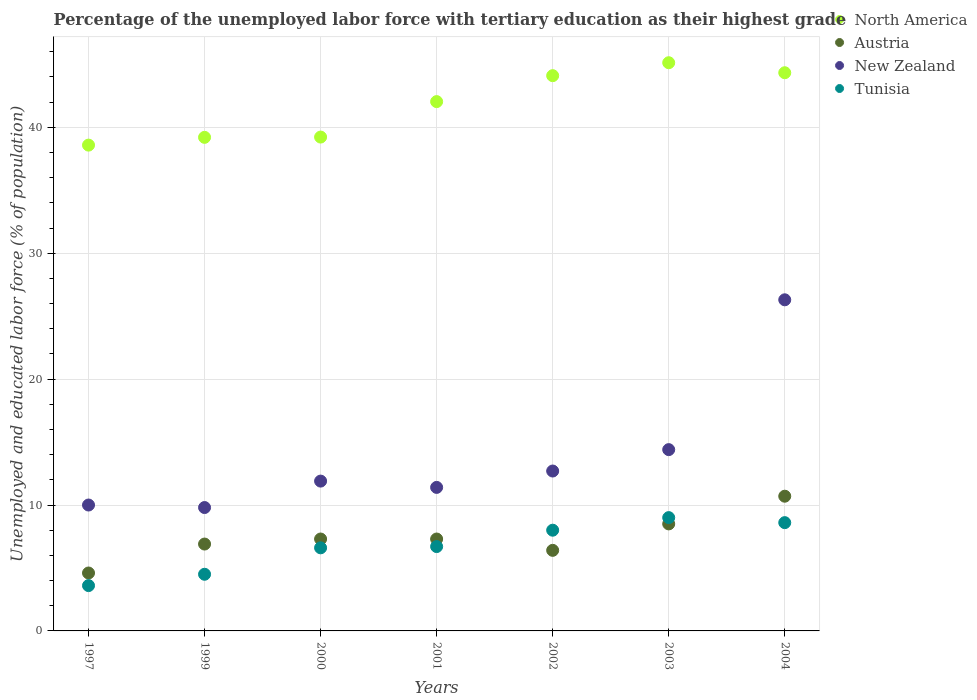How many different coloured dotlines are there?
Your answer should be very brief. 4. What is the percentage of the unemployed labor force with tertiary education in North America in 1997?
Ensure brevity in your answer.  38.59. Across all years, what is the maximum percentage of the unemployed labor force with tertiary education in Tunisia?
Give a very brief answer. 9. Across all years, what is the minimum percentage of the unemployed labor force with tertiary education in North America?
Your response must be concise. 38.59. What is the total percentage of the unemployed labor force with tertiary education in North America in the graph?
Provide a succinct answer. 292.63. What is the difference between the percentage of the unemployed labor force with tertiary education in Tunisia in 1999 and that in 2004?
Your response must be concise. -4.1. What is the difference between the percentage of the unemployed labor force with tertiary education in New Zealand in 1997 and the percentage of the unemployed labor force with tertiary education in Tunisia in 1999?
Make the answer very short. 5.5. What is the average percentage of the unemployed labor force with tertiary education in Tunisia per year?
Your answer should be compact. 6.71. In the year 2003, what is the difference between the percentage of the unemployed labor force with tertiary education in Austria and percentage of the unemployed labor force with tertiary education in New Zealand?
Your response must be concise. -5.9. What is the ratio of the percentage of the unemployed labor force with tertiary education in Austria in 2000 to that in 2004?
Keep it short and to the point. 0.68. Is the percentage of the unemployed labor force with tertiary education in North America in 2000 less than that in 2002?
Your response must be concise. Yes. Is the difference between the percentage of the unemployed labor force with tertiary education in Austria in 2001 and 2004 greater than the difference between the percentage of the unemployed labor force with tertiary education in New Zealand in 2001 and 2004?
Provide a succinct answer. Yes. What is the difference between the highest and the second highest percentage of the unemployed labor force with tertiary education in North America?
Offer a terse response. 0.8. What is the difference between the highest and the lowest percentage of the unemployed labor force with tertiary education in Austria?
Your response must be concise. 6.1. Is the sum of the percentage of the unemployed labor force with tertiary education in North America in 1999 and 2003 greater than the maximum percentage of the unemployed labor force with tertiary education in Tunisia across all years?
Offer a very short reply. Yes. Is it the case that in every year, the sum of the percentage of the unemployed labor force with tertiary education in New Zealand and percentage of the unemployed labor force with tertiary education in North America  is greater than the sum of percentage of the unemployed labor force with tertiary education in Austria and percentage of the unemployed labor force with tertiary education in Tunisia?
Offer a very short reply. Yes. Does the percentage of the unemployed labor force with tertiary education in North America monotonically increase over the years?
Your answer should be compact. No. Are the values on the major ticks of Y-axis written in scientific E-notation?
Your answer should be compact. No. Does the graph contain any zero values?
Your response must be concise. No. Where does the legend appear in the graph?
Your answer should be very brief. Top right. How many legend labels are there?
Keep it short and to the point. 4. What is the title of the graph?
Offer a very short reply. Percentage of the unemployed labor force with tertiary education as their highest grade. Does "Haiti" appear as one of the legend labels in the graph?
Make the answer very short. No. What is the label or title of the Y-axis?
Your response must be concise. Unemployed and educated labor force (% of population). What is the Unemployed and educated labor force (% of population) in North America in 1997?
Your answer should be compact. 38.59. What is the Unemployed and educated labor force (% of population) of Austria in 1997?
Offer a terse response. 4.6. What is the Unemployed and educated labor force (% of population) of Tunisia in 1997?
Keep it short and to the point. 3.6. What is the Unemployed and educated labor force (% of population) in North America in 1999?
Ensure brevity in your answer.  39.2. What is the Unemployed and educated labor force (% of population) of Austria in 1999?
Your answer should be compact. 6.9. What is the Unemployed and educated labor force (% of population) in New Zealand in 1999?
Provide a succinct answer. 9.8. What is the Unemployed and educated labor force (% of population) in North America in 2000?
Provide a short and direct response. 39.23. What is the Unemployed and educated labor force (% of population) in Austria in 2000?
Give a very brief answer. 7.3. What is the Unemployed and educated labor force (% of population) of New Zealand in 2000?
Offer a terse response. 11.9. What is the Unemployed and educated labor force (% of population) of Tunisia in 2000?
Your response must be concise. 6.6. What is the Unemployed and educated labor force (% of population) of North America in 2001?
Your answer should be very brief. 42.04. What is the Unemployed and educated labor force (% of population) of Austria in 2001?
Offer a very short reply. 7.3. What is the Unemployed and educated labor force (% of population) in New Zealand in 2001?
Provide a short and direct response. 11.4. What is the Unemployed and educated labor force (% of population) of Tunisia in 2001?
Provide a succinct answer. 6.7. What is the Unemployed and educated labor force (% of population) in North America in 2002?
Offer a very short reply. 44.1. What is the Unemployed and educated labor force (% of population) of Austria in 2002?
Keep it short and to the point. 6.4. What is the Unemployed and educated labor force (% of population) in New Zealand in 2002?
Make the answer very short. 12.7. What is the Unemployed and educated labor force (% of population) in North America in 2003?
Your answer should be very brief. 45.13. What is the Unemployed and educated labor force (% of population) of New Zealand in 2003?
Offer a terse response. 14.4. What is the Unemployed and educated labor force (% of population) in Tunisia in 2003?
Provide a succinct answer. 9. What is the Unemployed and educated labor force (% of population) in North America in 2004?
Give a very brief answer. 44.34. What is the Unemployed and educated labor force (% of population) of Austria in 2004?
Provide a short and direct response. 10.7. What is the Unemployed and educated labor force (% of population) of New Zealand in 2004?
Give a very brief answer. 26.3. What is the Unemployed and educated labor force (% of population) in Tunisia in 2004?
Ensure brevity in your answer.  8.6. Across all years, what is the maximum Unemployed and educated labor force (% of population) of North America?
Keep it short and to the point. 45.13. Across all years, what is the maximum Unemployed and educated labor force (% of population) of Austria?
Your response must be concise. 10.7. Across all years, what is the maximum Unemployed and educated labor force (% of population) in New Zealand?
Offer a very short reply. 26.3. Across all years, what is the maximum Unemployed and educated labor force (% of population) of Tunisia?
Your response must be concise. 9. Across all years, what is the minimum Unemployed and educated labor force (% of population) in North America?
Your answer should be very brief. 38.59. Across all years, what is the minimum Unemployed and educated labor force (% of population) of Austria?
Provide a short and direct response. 4.6. Across all years, what is the minimum Unemployed and educated labor force (% of population) in New Zealand?
Offer a terse response. 9.8. Across all years, what is the minimum Unemployed and educated labor force (% of population) in Tunisia?
Make the answer very short. 3.6. What is the total Unemployed and educated labor force (% of population) in North America in the graph?
Make the answer very short. 292.63. What is the total Unemployed and educated labor force (% of population) of Austria in the graph?
Ensure brevity in your answer.  51.7. What is the total Unemployed and educated labor force (% of population) in New Zealand in the graph?
Make the answer very short. 96.5. What is the total Unemployed and educated labor force (% of population) in Tunisia in the graph?
Keep it short and to the point. 47. What is the difference between the Unemployed and educated labor force (% of population) in North America in 1997 and that in 1999?
Offer a very short reply. -0.62. What is the difference between the Unemployed and educated labor force (% of population) in New Zealand in 1997 and that in 1999?
Your answer should be compact. 0.2. What is the difference between the Unemployed and educated labor force (% of population) of Tunisia in 1997 and that in 1999?
Your answer should be very brief. -0.9. What is the difference between the Unemployed and educated labor force (% of population) in North America in 1997 and that in 2000?
Give a very brief answer. -0.64. What is the difference between the Unemployed and educated labor force (% of population) of Austria in 1997 and that in 2000?
Make the answer very short. -2.7. What is the difference between the Unemployed and educated labor force (% of population) of New Zealand in 1997 and that in 2000?
Offer a very short reply. -1.9. What is the difference between the Unemployed and educated labor force (% of population) in Tunisia in 1997 and that in 2000?
Give a very brief answer. -3. What is the difference between the Unemployed and educated labor force (% of population) of North America in 1997 and that in 2001?
Give a very brief answer. -3.46. What is the difference between the Unemployed and educated labor force (% of population) in North America in 1997 and that in 2002?
Give a very brief answer. -5.52. What is the difference between the Unemployed and educated labor force (% of population) in Austria in 1997 and that in 2002?
Your response must be concise. -1.8. What is the difference between the Unemployed and educated labor force (% of population) in New Zealand in 1997 and that in 2002?
Your answer should be compact. -2.7. What is the difference between the Unemployed and educated labor force (% of population) in North America in 1997 and that in 2003?
Make the answer very short. -6.54. What is the difference between the Unemployed and educated labor force (% of population) of New Zealand in 1997 and that in 2003?
Keep it short and to the point. -4.4. What is the difference between the Unemployed and educated labor force (% of population) in North America in 1997 and that in 2004?
Your answer should be very brief. -5.75. What is the difference between the Unemployed and educated labor force (% of population) of Austria in 1997 and that in 2004?
Provide a succinct answer. -6.1. What is the difference between the Unemployed and educated labor force (% of population) of New Zealand in 1997 and that in 2004?
Keep it short and to the point. -16.3. What is the difference between the Unemployed and educated labor force (% of population) of Tunisia in 1997 and that in 2004?
Keep it short and to the point. -5. What is the difference between the Unemployed and educated labor force (% of population) in North America in 1999 and that in 2000?
Provide a succinct answer. -0.02. What is the difference between the Unemployed and educated labor force (% of population) in North America in 1999 and that in 2001?
Provide a short and direct response. -2.84. What is the difference between the Unemployed and educated labor force (% of population) in Austria in 1999 and that in 2001?
Your answer should be compact. -0.4. What is the difference between the Unemployed and educated labor force (% of population) in North America in 1999 and that in 2002?
Provide a short and direct response. -4.9. What is the difference between the Unemployed and educated labor force (% of population) of New Zealand in 1999 and that in 2002?
Provide a short and direct response. -2.9. What is the difference between the Unemployed and educated labor force (% of population) in North America in 1999 and that in 2003?
Your answer should be compact. -5.93. What is the difference between the Unemployed and educated labor force (% of population) of New Zealand in 1999 and that in 2003?
Ensure brevity in your answer.  -4.6. What is the difference between the Unemployed and educated labor force (% of population) of North America in 1999 and that in 2004?
Offer a very short reply. -5.13. What is the difference between the Unemployed and educated labor force (% of population) of Austria in 1999 and that in 2004?
Provide a short and direct response. -3.8. What is the difference between the Unemployed and educated labor force (% of population) in New Zealand in 1999 and that in 2004?
Ensure brevity in your answer.  -16.5. What is the difference between the Unemployed and educated labor force (% of population) in Tunisia in 1999 and that in 2004?
Offer a terse response. -4.1. What is the difference between the Unemployed and educated labor force (% of population) in North America in 2000 and that in 2001?
Offer a terse response. -2.82. What is the difference between the Unemployed and educated labor force (% of population) of Austria in 2000 and that in 2001?
Make the answer very short. 0. What is the difference between the Unemployed and educated labor force (% of population) of New Zealand in 2000 and that in 2001?
Ensure brevity in your answer.  0.5. What is the difference between the Unemployed and educated labor force (% of population) in Tunisia in 2000 and that in 2001?
Provide a succinct answer. -0.1. What is the difference between the Unemployed and educated labor force (% of population) of North America in 2000 and that in 2002?
Offer a very short reply. -4.88. What is the difference between the Unemployed and educated labor force (% of population) in Austria in 2000 and that in 2002?
Your response must be concise. 0.9. What is the difference between the Unemployed and educated labor force (% of population) in New Zealand in 2000 and that in 2002?
Offer a terse response. -0.8. What is the difference between the Unemployed and educated labor force (% of population) of Tunisia in 2000 and that in 2002?
Your answer should be very brief. -1.4. What is the difference between the Unemployed and educated labor force (% of population) of North America in 2000 and that in 2003?
Offer a terse response. -5.91. What is the difference between the Unemployed and educated labor force (% of population) of Austria in 2000 and that in 2003?
Provide a succinct answer. -1.2. What is the difference between the Unemployed and educated labor force (% of population) in New Zealand in 2000 and that in 2003?
Offer a terse response. -2.5. What is the difference between the Unemployed and educated labor force (% of population) in Tunisia in 2000 and that in 2003?
Offer a terse response. -2.4. What is the difference between the Unemployed and educated labor force (% of population) of North America in 2000 and that in 2004?
Your answer should be very brief. -5.11. What is the difference between the Unemployed and educated labor force (% of population) in Austria in 2000 and that in 2004?
Ensure brevity in your answer.  -3.4. What is the difference between the Unemployed and educated labor force (% of population) in New Zealand in 2000 and that in 2004?
Provide a short and direct response. -14.4. What is the difference between the Unemployed and educated labor force (% of population) of Tunisia in 2000 and that in 2004?
Provide a short and direct response. -2. What is the difference between the Unemployed and educated labor force (% of population) in North America in 2001 and that in 2002?
Your answer should be very brief. -2.06. What is the difference between the Unemployed and educated labor force (% of population) of North America in 2001 and that in 2003?
Your response must be concise. -3.09. What is the difference between the Unemployed and educated labor force (% of population) in Austria in 2001 and that in 2003?
Your answer should be very brief. -1.2. What is the difference between the Unemployed and educated labor force (% of population) of New Zealand in 2001 and that in 2003?
Keep it short and to the point. -3. What is the difference between the Unemployed and educated labor force (% of population) of Tunisia in 2001 and that in 2003?
Keep it short and to the point. -2.3. What is the difference between the Unemployed and educated labor force (% of population) of North America in 2001 and that in 2004?
Provide a short and direct response. -2.29. What is the difference between the Unemployed and educated labor force (% of population) of New Zealand in 2001 and that in 2004?
Offer a very short reply. -14.9. What is the difference between the Unemployed and educated labor force (% of population) in North America in 2002 and that in 2003?
Provide a succinct answer. -1.03. What is the difference between the Unemployed and educated labor force (% of population) in Tunisia in 2002 and that in 2003?
Provide a succinct answer. -1. What is the difference between the Unemployed and educated labor force (% of population) in North America in 2002 and that in 2004?
Give a very brief answer. -0.23. What is the difference between the Unemployed and educated labor force (% of population) in North America in 2003 and that in 2004?
Ensure brevity in your answer.  0.8. What is the difference between the Unemployed and educated labor force (% of population) in Tunisia in 2003 and that in 2004?
Provide a succinct answer. 0.4. What is the difference between the Unemployed and educated labor force (% of population) of North America in 1997 and the Unemployed and educated labor force (% of population) of Austria in 1999?
Provide a succinct answer. 31.69. What is the difference between the Unemployed and educated labor force (% of population) in North America in 1997 and the Unemployed and educated labor force (% of population) in New Zealand in 1999?
Make the answer very short. 28.79. What is the difference between the Unemployed and educated labor force (% of population) of North America in 1997 and the Unemployed and educated labor force (% of population) of Tunisia in 1999?
Offer a very short reply. 34.09. What is the difference between the Unemployed and educated labor force (% of population) in Austria in 1997 and the Unemployed and educated labor force (% of population) in Tunisia in 1999?
Keep it short and to the point. 0.1. What is the difference between the Unemployed and educated labor force (% of population) of North America in 1997 and the Unemployed and educated labor force (% of population) of Austria in 2000?
Keep it short and to the point. 31.29. What is the difference between the Unemployed and educated labor force (% of population) in North America in 1997 and the Unemployed and educated labor force (% of population) in New Zealand in 2000?
Provide a succinct answer. 26.69. What is the difference between the Unemployed and educated labor force (% of population) in North America in 1997 and the Unemployed and educated labor force (% of population) in Tunisia in 2000?
Your answer should be compact. 31.99. What is the difference between the Unemployed and educated labor force (% of population) in Austria in 1997 and the Unemployed and educated labor force (% of population) in New Zealand in 2000?
Ensure brevity in your answer.  -7.3. What is the difference between the Unemployed and educated labor force (% of population) in Austria in 1997 and the Unemployed and educated labor force (% of population) in Tunisia in 2000?
Give a very brief answer. -2. What is the difference between the Unemployed and educated labor force (% of population) in New Zealand in 1997 and the Unemployed and educated labor force (% of population) in Tunisia in 2000?
Give a very brief answer. 3.4. What is the difference between the Unemployed and educated labor force (% of population) in North America in 1997 and the Unemployed and educated labor force (% of population) in Austria in 2001?
Offer a terse response. 31.29. What is the difference between the Unemployed and educated labor force (% of population) of North America in 1997 and the Unemployed and educated labor force (% of population) of New Zealand in 2001?
Your answer should be very brief. 27.19. What is the difference between the Unemployed and educated labor force (% of population) in North America in 1997 and the Unemployed and educated labor force (% of population) in Tunisia in 2001?
Offer a terse response. 31.89. What is the difference between the Unemployed and educated labor force (% of population) of Austria in 1997 and the Unemployed and educated labor force (% of population) of Tunisia in 2001?
Your answer should be very brief. -2.1. What is the difference between the Unemployed and educated labor force (% of population) in New Zealand in 1997 and the Unemployed and educated labor force (% of population) in Tunisia in 2001?
Offer a very short reply. 3.3. What is the difference between the Unemployed and educated labor force (% of population) in North America in 1997 and the Unemployed and educated labor force (% of population) in Austria in 2002?
Offer a terse response. 32.19. What is the difference between the Unemployed and educated labor force (% of population) of North America in 1997 and the Unemployed and educated labor force (% of population) of New Zealand in 2002?
Your answer should be very brief. 25.89. What is the difference between the Unemployed and educated labor force (% of population) of North America in 1997 and the Unemployed and educated labor force (% of population) of Tunisia in 2002?
Provide a short and direct response. 30.59. What is the difference between the Unemployed and educated labor force (% of population) of Austria in 1997 and the Unemployed and educated labor force (% of population) of New Zealand in 2002?
Your answer should be very brief. -8.1. What is the difference between the Unemployed and educated labor force (% of population) of North America in 1997 and the Unemployed and educated labor force (% of population) of Austria in 2003?
Your answer should be very brief. 30.09. What is the difference between the Unemployed and educated labor force (% of population) in North America in 1997 and the Unemployed and educated labor force (% of population) in New Zealand in 2003?
Your answer should be very brief. 24.19. What is the difference between the Unemployed and educated labor force (% of population) in North America in 1997 and the Unemployed and educated labor force (% of population) in Tunisia in 2003?
Your answer should be compact. 29.59. What is the difference between the Unemployed and educated labor force (% of population) in Austria in 1997 and the Unemployed and educated labor force (% of population) in Tunisia in 2003?
Provide a short and direct response. -4.4. What is the difference between the Unemployed and educated labor force (% of population) of North America in 1997 and the Unemployed and educated labor force (% of population) of Austria in 2004?
Your response must be concise. 27.89. What is the difference between the Unemployed and educated labor force (% of population) in North America in 1997 and the Unemployed and educated labor force (% of population) in New Zealand in 2004?
Give a very brief answer. 12.29. What is the difference between the Unemployed and educated labor force (% of population) of North America in 1997 and the Unemployed and educated labor force (% of population) of Tunisia in 2004?
Ensure brevity in your answer.  29.99. What is the difference between the Unemployed and educated labor force (% of population) in Austria in 1997 and the Unemployed and educated labor force (% of population) in New Zealand in 2004?
Give a very brief answer. -21.7. What is the difference between the Unemployed and educated labor force (% of population) in North America in 1999 and the Unemployed and educated labor force (% of population) in Austria in 2000?
Offer a terse response. 31.9. What is the difference between the Unemployed and educated labor force (% of population) in North America in 1999 and the Unemployed and educated labor force (% of population) in New Zealand in 2000?
Offer a very short reply. 27.3. What is the difference between the Unemployed and educated labor force (% of population) in North America in 1999 and the Unemployed and educated labor force (% of population) in Tunisia in 2000?
Your answer should be very brief. 32.6. What is the difference between the Unemployed and educated labor force (% of population) of Austria in 1999 and the Unemployed and educated labor force (% of population) of New Zealand in 2000?
Offer a terse response. -5. What is the difference between the Unemployed and educated labor force (% of population) in Austria in 1999 and the Unemployed and educated labor force (% of population) in Tunisia in 2000?
Your response must be concise. 0.3. What is the difference between the Unemployed and educated labor force (% of population) of New Zealand in 1999 and the Unemployed and educated labor force (% of population) of Tunisia in 2000?
Your answer should be compact. 3.2. What is the difference between the Unemployed and educated labor force (% of population) in North America in 1999 and the Unemployed and educated labor force (% of population) in Austria in 2001?
Offer a very short reply. 31.9. What is the difference between the Unemployed and educated labor force (% of population) in North America in 1999 and the Unemployed and educated labor force (% of population) in New Zealand in 2001?
Your answer should be compact. 27.8. What is the difference between the Unemployed and educated labor force (% of population) in North America in 1999 and the Unemployed and educated labor force (% of population) in Tunisia in 2001?
Your answer should be very brief. 32.5. What is the difference between the Unemployed and educated labor force (% of population) of Austria in 1999 and the Unemployed and educated labor force (% of population) of New Zealand in 2001?
Keep it short and to the point. -4.5. What is the difference between the Unemployed and educated labor force (% of population) of New Zealand in 1999 and the Unemployed and educated labor force (% of population) of Tunisia in 2001?
Your answer should be very brief. 3.1. What is the difference between the Unemployed and educated labor force (% of population) in North America in 1999 and the Unemployed and educated labor force (% of population) in Austria in 2002?
Provide a succinct answer. 32.8. What is the difference between the Unemployed and educated labor force (% of population) of North America in 1999 and the Unemployed and educated labor force (% of population) of New Zealand in 2002?
Provide a succinct answer. 26.5. What is the difference between the Unemployed and educated labor force (% of population) in North America in 1999 and the Unemployed and educated labor force (% of population) in Tunisia in 2002?
Your answer should be very brief. 31.2. What is the difference between the Unemployed and educated labor force (% of population) of Austria in 1999 and the Unemployed and educated labor force (% of population) of Tunisia in 2002?
Your response must be concise. -1.1. What is the difference between the Unemployed and educated labor force (% of population) in North America in 1999 and the Unemployed and educated labor force (% of population) in Austria in 2003?
Offer a terse response. 30.7. What is the difference between the Unemployed and educated labor force (% of population) in North America in 1999 and the Unemployed and educated labor force (% of population) in New Zealand in 2003?
Give a very brief answer. 24.8. What is the difference between the Unemployed and educated labor force (% of population) of North America in 1999 and the Unemployed and educated labor force (% of population) of Tunisia in 2003?
Provide a succinct answer. 30.2. What is the difference between the Unemployed and educated labor force (% of population) of New Zealand in 1999 and the Unemployed and educated labor force (% of population) of Tunisia in 2003?
Ensure brevity in your answer.  0.8. What is the difference between the Unemployed and educated labor force (% of population) in North America in 1999 and the Unemployed and educated labor force (% of population) in Austria in 2004?
Make the answer very short. 28.5. What is the difference between the Unemployed and educated labor force (% of population) of North America in 1999 and the Unemployed and educated labor force (% of population) of New Zealand in 2004?
Your answer should be compact. 12.9. What is the difference between the Unemployed and educated labor force (% of population) in North America in 1999 and the Unemployed and educated labor force (% of population) in Tunisia in 2004?
Make the answer very short. 30.6. What is the difference between the Unemployed and educated labor force (% of population) of Austria in 1999 and the Unemployed and educated labor force (% of population) of New Zealand in 2004?
Offer a terse response. -19.4. What is the difference between the Unemployed and educated labor force (% of population) in New Zealand in 1999 and the Unemployed and educated labor force (% of population) in Tunisia in 2004?
Ensure brevity in your answer.  1.2. What is the difference between the Unemployed and educated labor force (% of population) in North America in 2000 and the Unemployed and educated labor force (% of population) in Austria in 2001?
Your answer should be compact. 31.93. What is the difference between the Unemployed and educated labor force (% of population) in North America in 2000 and the Unemployed and educated labor force (% of population) in New Zealand in 2001?
Your answer should be very brief. 27.83. What is the difference between the Unemployed and educated labor force (% of population) in North America in 2000 and the Unemployed and educated labor force (% of population) in Tunisia in 2001?
Offer a terse response. 32.53. What is the difference between the Unemployed and educated labor force (% of population) of Austria in 2000 and the Unemployed and educated labor force (% of population) of New Zealand in 2001?
Provide a short and direct response. -4.1. What is the difference between the Unemployed and educated labor force (% of population) in North America in 2000 and the Unemployed and educated labor force (% of population) in Austria in 2002?
Keep it short and to the point. 32.83. What is the difference between the Unemployed and educated labor force (% of population) of North America in 2000 and the Unemployed and educated labor force (% of population) of New Zealand in 2002?
Your response must be concise. 26.53. What is the difference between the Unemployed and educated labor force (% of population) of North America in 2000 and the Unemployed and educated labor force (% of population) of Tunisia in 2002?
Your answer should be very brief. 31.23. What is the difference between the Unemployed and educated labor force (% of population) in Austria in 2000 and the Unemployed and educated labor force (% of population) in New Zealand in 2002?
Give a very brief answer. -5.4. What is the difference between the Unemployed and educated labor force (% of population) in Austria in 2000 and the Unemployed and educated labor force (% of population) in Tunisia in 2002?
Give a very brief answer. -0.7. What is the difference between the Unemployed and educated labor force (% of population) in North America in 2000 and the Unemployed and educated labor force (% of population) in Austria in 2003?
Provide a short and direct response. 30.73. What is the difference between the Unemployed and educated labor force (% of population) in North America in 2000 and the Unemployed and educated labor force (% of population) in New Zealand in 2003?
Provide a short and direct response. 24.83. What is the difference between the Unemployed and educated labor force (% of population) in North America in 2000 and the Unemployed and educated labor force (% of population) in Tunisia in 2003?
Provide a succinct answer. 30.23. What is the difference between the Unemployed and educated labor force (% of population) in North America in 2000 and the Unemployed and educated labor force (% of population) in Austria in 2004?
Ensure brevity in your answer.  28.53. What is the difference between the Unemployed and educated labor force (% of population) of North America in 2000 and the Unemployed and educated labor force (% of population) of New Zealand in 2004?
Provide a succinct answer. 12.93. What is the difference between the Unemployed and educated labor force (% of population) in North America in 2000 and the Unemployed and educated labor force (% of population) in Tunisia in 2004?
Provide a short and direct response. 30.63. What is the difference between the Unemployed and educated labor force (% of population) of Austria in 2000 and the Unemployed and educated labor force (% of population) of New Zealand in 2004?
Ensure brevity in your answer.  -19. What is the difference between the Unemployed and educated labor force (% of population) in New Zealand in 2000 and the Unemployed and educated labor force (% of population) in Tunisia in 2004?
Offer a very short reply. 3.3. What is the difference between the Unemployed and educated labor force (% of population) in North America in 2001 and the Unemployed and educated labor force (% of population) in Austria in 2002?
Provide a short and direct response. 35.64. What is the difference between the Unemployed and educated labor force (% of population) of North America in 2001 and the Unemployed and educated labor force (% of population) of New Zealand in 2002?
Keep it short and to the point. 29.34. What is the difference between the Unemployed and educated labor force (% of population) in North America in 2001 and the Unemployed and educated labor force (% of population) in Tunisia in 2002?
Offer a very short reply. 34.04. What is the difference between the Unemployed and educated labor force (% of population) in Austria in 2001 and the Unemployed and educated labor force (% of population) in Tunisia in 2002?
Provide a short and direct response. -0.7. What is the difference between the Unemployed and educated labor force (% of population) of New Zealand in 2001 and the Unemployed and educated labor force (% of population) of Tunisia in 2002?
Offer a terse response. 3.4. What is the difference between the Unemployed and educated labor force (% of population) in North America in 2001 and the Unemployed and educated labor force (% of population) in Austria in 2003?
Provide a succinct answer. 33.54. What is the difference between the Unemployed and educated labor force (% of population) in North America in 2001 and the Unemployed and educated labor force (% of population) in New Zealand in 2003?
Ensure brevity in your answer.  27.64. What is the difference between the Unemployed and educated labor force (% of population) in North America in 2001 and the Unemployed and educated labor force (% of population) in Tunisia in 2003?
Make the answer very short. 33.04. What is the difference between the Unemployed and educated labor force (% of population) in Austria in 2001 and the Unemployed and educated labor force (% of population) in New Zealand in 2003?
Provide a succinct answer. -7.1. What is the difference between the Unemployed and educated labor force (% of population) in Austria in 2001 and the Unemployed and educated labor force (% of population) in Tunisia in 2003?
Your answer should be very brief. -1.7. What is the difference between the Unemployed and educated labor force (% of population) of North America in 2001 and the Unemployed and educated labor force (% of population) of Austria in 2004?
Provide a succinct answer. 31.34. What is the difference between the Unemployed and educated labor force (% of population) of North America in 2001 and the Unemployed and educated labor force (% of population) of New Zealand in 2004?
Your answer should be very brief. 15.74. What is the difference between the Unemployed and educated labor force (% of population) of North America in 2001 and the Unemployed and educated labor force (% of population) of Tunisia in 2004?
Your answer should be compact. 33.44. What is the difference between the Unemployed and educated labor force (% of population) in Austria in 2001 and the Unemployed and educated labor force (% of population) in New Zealand in 2004?
Your answer should be very brief. -19. What is the difference between the Unemployed and educated labor force (% of population) in New Zealand in 2001 and the Unemployed and educated labor force (% of population) in Tunisia in 2004?
Your response must be concise. 2.8. What is the difference between the Unemployed and educated labor force (% of population) of North America in 2002 and the Unemployed and educated labor force (% of population) of Austria in 2003?
Give a very brief answer. 35.6. What is the difference between the Unemployed and educated labor force (% of population) in North America in 2002 and the Unemployed and educated labor force (% of population) in New Zealand in 2003?
Your answer should be very brief. 29.7. What is the difference between the Unemployed and educated labor force (% of population) in North America in 2002 and the Unemployed and educated labor force (% of population) in Tunisia in 2003?
Make the answer very short. 35.1. What is the difference between the Unemployed and educated labor force (% of population) in Austria in 2002 and the Unemployed and educated labor force (% of population) in New Zealand in 2003?
Your answer should be very brief. -8. What is the difference between the Unemployed and educated labor force (% of population) of Austria in 2002 and the Unemployed and educated labor force (% of population) of Tunisia in 2003?
Provide a short and direct response. -2.6. What is the difference between the Unemployed and educated labor force (% of population) in North America in 2002 and the Unemployed and educated labor force (% of population) in Austria in 2004?
Keep it short and to the point. 33.4. What is the difference between the Unemployed and educated labor force (% of population) in North America in 2002 and the Unemployed and educated labor force (% of population) in New Zealand in 2004?
Your answer should be compact. 17.8. What is the difference between the Unemployed and educated labor force (% of population) of North America in 2002 and the Unemployed and educated labor force (% of population) of Tunisia in 2004?
Your answer should be very brief. 35.5. What is the difference between the Unemployed and educated labor force (% of population) in Austria in 2002 and the Unemployed and educated labor force (% of population) in New Zealand in 2004?
Provide a short and direct response. -19.9. What is the difference between the Unemployed and educated labor force (% of population) in Austria in 2002 and the Unemployed and educated labor force (% of population) in Tunisia in 2004?
Your answer should be very brief. -2.2. What is the difference between the Unemployed and educated labor force (% of population) in North America in 2003 and the Unemployed and educated labor force (% of population) in Austria in 2004?
Ensure brevity in your answer.  34.43. What is the difference between the Unemployed and educated labor force (% of population) of North America in 2003 and the Unemployed and educated labor force (% of population) of New Zealand in 2004?
Offer a terse response. 18.83. What is the difference between the Unemployed and educated labor force (% of population) of North America in 2003 and the Unemployed and educated labor force (% of population) of Tunisia in 2004?
Make the answer very short. 36.53. What is the difference between the Unemployed and educated labor force (% of population) in Austria in 2003 and the Unemployed and educated labor force (% of population) in New Zealand in 2004?
Offer a terse response. -17.8. What is the average Unemployed and educated labor force (% of population) in North America per year?
Provide a short and direct response. 41.8. What is the average Unemployed and educated labor force (% of population) in Austria per year?
Your answer should be compact. 7.39. What is the average Unemployed and educated labor force (% of population) of New Zealand per year?
Offer a terse response. 13.79. What is the average Unemployed and educated labor force (% of population) of Tunisia per year?
Your answer should be very brief. 6.71. In the year 1997, what is the difference between the Unemployed and educated labor force (% of population) of North America and Unemployed and educated labor force (% of population) of Austria?
Provide a short and direct response. 33.99. In the year 1997, what is the difference between the Unemployed and educated labor force (% of population) of North America and Unemployed and educated labor force (% of population) of New Zealand?
Your response must be concise. 28.59. In the year 1997, what is the difference between the Unemployed and educated labor force (% of population) of North America and Unemployed and educated labor force (% of population) of Tunisia?
Your answer should be compact. 34.99. In the year 1999, what is the difference between the Unemployed and educated labor force (% of population) in North America and Unemployed and educated labor force (% of population) in Austria?
Offer a terse response. 32.3. In the year 1999, what is the difference between the Unemployed and educated labor force (% of population) of North America and Unemployed and educated labor force (% of population) of New Zealand?
Ensure brevity in your answer.  29.4. In the year 1999, what is the difference between the Unemployed and educated labor force (% of population) of North America and Unemployed and educated labor force (% of population) of Tunisia?
Offer a terse response. 34.7. In the year 1999, what is the difference between the Unemployed and educated labor force (% of population) of New Zealand and Unemployed and educated labor force (% of population) of Tunisia?
Ensure brevity in your answer.  5.3. In the year 2000, what is the difference between the Unemployed and educated labor force (% of population) in North America and Unemployed and educated labor force (% of population) in Austria?
Provide a short and direct response. 31.93. In the year 2000, what is the difference between the Unemployed and educated labor force (% of population) of North America and Unemployed and educated labor force (% of population) of New Zealand?
Ensure brevity in your answer.  27.33. In the year 2000, what is the difference between the Unemployed and educated labor force (% of population) of North America and Unemployed and educated labor force (% of population) of Tunisia?
Your answer should be very brief. 32.63. In the year 2000, what is the difference between the Unemployed and educated labor force (% of population) of Austria and Unemployed and educated labor force (% of population) of Tunisia?
Provide a short and direct response. 0.7. In the year 2001, what is the difference between the Unemployed and educated labor force (% of population) in North America and Unemployed and educated labor force (% of population) in Austria?
Provide a succinct answer. 34.74. In the year 2001, what is the difference between the Unemployed and educated labor force (% of population) in North America and Unemployed and educated labor force (% of population) in New Zealand?
Provide a short and direct response. 30.64. In the year 2001, what is the difference between the Unemployed and educated labor force (% of population) in North America and Unemployed and educated labor force (% of population) in Tunisia?
Make the answer very short. 35.34. In the year 2001, what is the difference between the Unemployed and educated labor force (% of population) in Austria and Unemployed and educated labor force (% of population) in New Zealand?
Provide a succinct answer. -4.1. In the year 2001, what is the difference between the Unemployed and educated labor force (% of population) of New Zealand and Unemployed and educated labor force (% of population) of Tunisia?
Your answer should be very brief. 4.7. In the year 2002, what is the difference between the Unemployed and educated labor force (% of population) in North America and Unemployed and educated labor force (% of population) in Austria?
Your response must be concise. 37.7. In the year 2002, what is the difference between the Unemployed and educated labor force (% of population) in North America and Unemployed and educated labor force (% of population) in New Zealand?
Offer a terse response. 31.4. In the year 2002, what is the difference between the Unemployed and educated labor force (% of population) in North America and Unemployed and educated labor force (% of population) in Tunisia?
Offer a terse response. 36.1. In the year 2002, what is the difference between the Unemployed and educated labor force (% of population) of Austria and Unemployed and educated labor force (% of population) of New Zealand?
Provide a succinct answer. -6.3. In the year 2002, what is the difference between the Unemployed and educated labor force (% of population) of Austria and Unemployed and educated labor force (% of population) of Tunisia?
Keep it short and to the point. -1.6. In the year 2002, what is the difference between the Unemployed and educated labor force (% of population) of New Zealand and Unemployed and educated labor force (% of population) of Tunisia?
Your response must be concise. 4.7. In the year 2003, what is the difference between the Unemployed and educated labor force (% of population) of North America and Unemployed and educated labor force (% of population) of Austria?
Provide a succinct answer. 36.63. In the year 2003, what is the difference between the Unemployed and educated labor force (% of population) in North America and Unemployed and educated labor force (% of population) in New Zealand?
Your answer should be compact. 30.73. In the year 2003, what is the difference between the Unemployed and educated labor force (% of population) in North America and Unemployed and educated labor force (% of population) in Tunisia?
Offer a terse response. 36.13. In the year 2003, what is the difference between the Unemployed and educated labor force (% of population) in Austria and Unemployed and educated labor force (% of population) in New Zealand?
Your answer should be very brief. -5.9. In the year 2003, what is the difference between the Unemployed and educated labor force (% of population) of New Zealand and Unemployed and educated labor force (% of population) of Tunisia?
Keep it short and to the point. 5.4. In the year 2004, what is the difference between the Unemployed and educated labor force (% of population) in North America and Unemployed and educated labor force (% of population) in Austria?
Your answer should be very brief. 33.64. In the year 2004, what is the difference between the Unemployed and educated labor force (% of population) in North America and Unemployed and educated labor force (% of population) in New Zealand?
Offer a very short reply. 18.04. In the year 2004, what is the difference between the Unemployed and educated labor force (% of population) in North America and Unemployed and educated labor force (% of population) in Tunisia?
Your answer should be compact. 35.74. In the year 2004, what is the difference between the Unemployed and educated labor force (% of population) of Austria and Unemployed and educated labor force (% of population) of New Zealand?
Offer a very short reply. -15.6. In the year 2004, what is the difference between the Unemployed and educated labor force (% of population) of Austria and Unemployed and educated labor force (% of population) of Tunisia?
Provide a succinct answer. 2.1. What is the ratio of the Unemployed and educated labor force (% of population) of North America in 1997 to that in 1999?
Offer a very short reply. 0.98. What is the ratio of the Unemployed and educated labor force (% of population) in Austria in 1997 to that in 1999?
Offer a very short reply. 0.67. What is the ratio of the Unemployed and educated labor force (% of population) of New Zealand in 1997 to that in 1999?
Offer a terse response. 1.02. What is the ratio of the Unemployed and educated labor force (% of population) of North America in 1997 to that in 2000?
Your answer should be very brief. 0.98. What is the ratio of the Unemployed and educated labor force (% of population) of Austria in 1997 to that in 2000?
Provide a short and direct response. 0.63. What is the ratio of the Unemployed and educated labor force (% of population) in New Zealand in 1997 to that in 2000?
Give a very brief answer. 0.84. What is the ratio of the Unemployed and educated labor force (% of population) of Tunisia in 1997 to that in 2000?
Offer a terse response. 0.55. What is the ratio of the Unemployed and educated labor force (% of population) of North America in 1997 to that in 2001?
Your answer should be very brief. 0.92. What is the ratio of the Unemployed and educated labor force (% of population) of Austria in 1997 to that in 2001?
Offer a terse response. 0.63. What is the ratio of the Unemployed and educated labor force (% of population) in New Zealand in 1997 to that in 2001?
Offer a terse response. 0.88. What is the ratio of the Unemployed and educated labor force (% of population) of Tunisia in 1997 to that in 2001?
Your answer should be very brief. 0.54. What is the ratio of the Unemployed and educated labor force (% of population) in North America in 1997 to that in 2002?
Make the answer very short. 0.87. What is the ratio of the Unemployed and educated labor force (% of population) of Austria in 1997 to that in 2002?
Offer a terse response. 0.72. What is the ratio of the Unemployed and educated labor force (% of population) in New Zealand in 1997 to that in 2002?
Provide a short and direct response. 0.79. What is the ratio of the Unemployed and educated labor force (% of population) in Tunisia in 1997 to that in 2002?
Your answer should be compact. 0.45. What is the ratio of the Unemployed and educated labor force (% of population) of North America in 1997 to that in 2003?
Your answer should be compact. 0.85. What is the ratio of the Unemployed and educated labor force (% of population) in Austria in 1997 to that in 2003?
Your answer should be very brief. 0.54. What is the ratio of the Unemployed and educated labor force (% of population) in New Zealand in 1997 to that in 2003?
Your response must be concise. 0.69. What is the ratio of the Unemployed and educated labor force (% of population) of North America in 1997 to that in 2004?
Offer a very short reply. 0.87. What is the ratio of the Unemployed and educated labor force (% of population) of Austria in 1997 to that in 2004?
Provide a short and direct response. 0.43. What is the ratio of the Unemployed and educated labor force (% of population) in New Zealand in 1997 to that in 2004?
Keep it short and to the point. 0.38. What is the ratio of the Unemployed and educated labor force (% of population) of Tunisia in 1997 to that in 2004?
Offer a terse response. 0.42. What is the ratio of the Unemployed and educated labor force (% of population) of North America in 1999 to that in 2000?
Your response must be concise. 1. What is the ratio of the Unemployed and educated labor force (% of population) of Austria in 1999 to that in 2000?
Ensure brevity in your answer.  0.95. What is the ratio of the Unemployed and educated labor force (% of population) in New Zealand in 1999 to that in 2000?
Ensure brevity in your answer.  0.82. What is the ratio of the Unemployed and educated labor force (% of population) of Tunisia in 1999 to that in 2000?
Make the answer very short. 0.68. What is the ratio of the Unemployed and educated labor force (% of population) of North America in 1999 to that in 2001?
Make the answer very short. 0.93. What is the ratio of the Unemployed and educated labor force (% of population) of Austria in 1999 to that in 2001?
Provide a short and direct response. 0.95. What is the ratio of the Unemployed and educated labor force (% of population) of New Zealand in 1999 to that in 2001?
Ensure brevity in your answer.  0.86. What is the ratio of the Unemployed and educated labor force (% of population) in Tunisia in 1999 to that in 2001?
Your answer should be very brief. 0.67. What is the ratio of the Unemployed and educated labor force (% of population) of North America in 1999 to that in 2002?
Your answer should be very brief. 0.89. What is the ratio of the Unemployed and educated labor force (% of population) in Austria in 1999 to that in 2002?
Ensure brevity in your answer.  1.08. What is the ratio of the Unemployed and educated labor force (% of population) in New Zealand in 1999 to that in 2002?
Provide a short and direct response. 0.77. What is the ratio of the Unemployed and educated labor force (% of population) of Tunisia in 1999 to that in 2002?
Ensure brevity in your answer.  0.56. What is the ratio of the Unemployed and educated labor force (% of population) in North America in 1999 to that in 2003?
Your answer should be very brief. 0.87. What is the ratio of the Unemployed and educated labor force (% of population) in Austria in 1999 to that in 2003?
Keep it short and to the point. 0.81. What is the ratio of the Unemployed and educated labor force (% of population) of New Zealand in 1999 to that in 2003?
Offer a terse response. 0.68. What is the ratio of the Unemployed and educated labor force (% of population) in Tunisia in 1999 to that in 2003?
Your answer should be compact. 0.5. What is the ratio of the Unemployed and educated labor force (% of population) of North America in 1999 to that in 2004?
Provide a succinct answer. 0.88. What is the ratio of the Unemployed and educated labor force (% of population) in Austria in 1999 to that in 2004?
Offer a terse response. 0.64. What is the ratio of the Unemployed and educated labor force (% of population) in New Zealand in 1999 to that in 2004?
Give a very brief answer. 0.37. What is the ratio of the Unemployed and educated labor force (% of population) in Tunisia in 1999 to that in 2004?
Offer a terse response. 0.52. What is the ratio of the Unemployed and educated labor force (% of population) in North America in 2000 to that in 2001?
Your answer should be very brief. 0.93. What is the ratio of the Unemployed and educated labor force (% of population) in Austria in 2000 to that in 2001?
Make the answer very short. 1. What is the ratio of the Unemployed and educated labor force (% of population) in New Zealand in 2000 to that in 2001?
Offer a very short reply. 1.04. What is the ratio of the Unemployed and educated labor force (% of population) in Tunisia in 2000 to that in 2001?
Offer a very short reply. 0.99. What is the ratio of the Unemployed and educated labor force (% of population) in North America in 2000 to that in 2002?
Provide a succinct answer. 0.89. What is the ratio of the Unemployed and educated labor force (% of population) of Austria in 2000 to that in 2002?
Offer a very short reply. 1.14. What is the ratio of the Unemployed and educated labor force (% of population) of New Zealand in 2000 to that in 2002?
Your answer should be compact. 0.94. What is the ratio of the Unemployed and educated labor force (% of population) in Tunisia in 2000 to that in 2002?
Provide a succinct answer. 0.82. What is the ratio of the Unemployed and educated labor force (% of population) in North America in 2000 to that in 2003?
Offer a very short reply. 0.87. What is the ratio of the Unemployed and educated labor force (% of population) in Austria in 2000 to that in 2003?
Offer a very short reply. 0.86. What is the ratio of the Unemployed and educated labor force (% of population) in New Zealand in 2000 to that in 2003?
Your response must be concise. 0.83. What is the ratio of the Unemployed and educated labor force (% of population) of Tunisia in 2000 to that in 2003?
Ensure brevity in your answer.  0.73. What is the ratio of the Unemployed and educated labor force (% of population) of North America in 2000 to that in 2004?
Provide a short and direct response. 0.88. What is the ratio of the Unemployed and educated labor force (% of population) in Austria in 2000 to that in 2004?
Make the answer very short. 0.68. What is the ratio of the Unemployed and educated labor force (% of population) of New Zealand in 2000 to that in 2004?
Provide a short and direct response. 0.45. What is the ratio of the Unemployed and educated labor force (% of population) of Tunisia in 2000 to that in 2004?
Provide a succinct answer. 0.77. What is the ratio of the Unemployed and educated labor force (% of population) of North America in 2001 to that in 2002?
Your answer should be compact. 0.95. What is the ratio of the Unemployed and educated labor force (% of population) in Austria in 2001 to that in 2002?
Offer a terse response. 1.14. What is the ratio of the Unemployed and educated labor force (% of population) of New Zealand in 2001 to that in 2002?
Offer a very short reply. 0.9. What is the ratio of the Unemployed and educated labor force (% of population) of Tunisia in 2001 to that in 2002?
Offer a terse response. 0.84. What is the ratio of the Unemployed and educated labor force (% of population) in North America in 2001 to that in 2003?
Offer a very short reply. 0.93. What is the ratio of the Unemployed and educated labor force (% of population) of Austria in 2001 to that in 2003?
Give a very brief answer. 0.86. What is the ratio of the Unemployed and educated labor force (% of population) in New Zealand in 2001 to that in 2003?
Provide a short and direct response. 0.79. What is the ratio of the Unemployed and educated labor force (% of population) in Tunisia in 2001 to that in 2003?
Provide a short and direct response. 0.74. What is the ratio of the Unemployed and educated labor force (% of population) of North America in 2001 to that in 2004?
Ensure brevity in your answer.  0.95. What is the ratio of the Unemployed and educated labor force (% of population) of Austria in 2001 to that in 2004?
Offer a very short reply. 0.68. What is the ratio of the Unemployed and educated labor force (% of population) of New Zealand in 2001 to that in 2004?
Provide a succinct answer. 0.43. What is the ratio of the Unemployed and educated labor force (% of population) of Tunisia in 2001 to that in 2004?
Provide a short and direct response. 0.78. What is the ratio of the Unemployed and educated labor force (% of population) in North America in 2002 to that in 2003?
Ensure brevity in your answer.  0.98. What is the ratio of the Unemployed and educated labor force (% of population) of Austria in 2002 to that in 2003?
Keep it short and to the point. 0.75. What is the ratio of the Unemployed and educated labor force (% of population) in New Zealand in 2002 to that in 2003?
Give a very brief answer. 0.88. What is the ratio of the Unemployed and educated labor force (% of population) in Austria in 2002 to that in 2004?
Your answer should be very brief. 0.6. What is the ratio of the Unemployed and educated labor force (% of population) in New Zealand in 2002 to that in 2004?
Give a very brief answer. 0.48. What is the ratio of the Unemployed and educated labor force (% of population) in Tunisia in 2002 to that in 2004?
Your answer should be very brief. 0.93. What is the ratio of the Unemployed and educated labor force (% of population) in North America in 2003 to that in 2004?
Ensure brevity in your answer.  1.02. What is the ratio of the Unemployed and educated labor force (% of population) of Austria in 2003 to that in 2004?
Keep it short and to the point. 0.79. What is the ratio of the Unemployed and educated labor force (% of population) in New Zealand in 2003 to that in 2004?
Your answer should be compact. 0.55. What is the ratio of the Unemployed and educated labor force (% of population) in Tunisia in 2003 to that in 2004?
Your answer should be compact. 1.05. What is the difference between the highest and the second highest Unemployed and educated labor force (% of population) of North America?
Provide a succinct answer. 0.8. What is the difference between the highest and the second highest Unemployed and educated labor force (% of population) in Austria?
Offer a very short reply. 2.2. What is the difference between the highest and the second highest Unemployed and educated labor force (% of population) of New Zealand?
Your answer should be compact. 11.9. What is the difference between the highest and the lowest Unemployed and educated labor force (% of population) in North America?
Give a very brief answer. 6.54. What is the difference between the highest and the lowest Unemployed and educated labor force (% of population) of Austria?
Keep it short and to the point. 6.1. What is the difference between the highest and the lowest Unemployed and educated labor force (% of population) of New Zealand?
Keep it short and to the point. 16.5. 